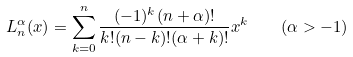Convert formula to latex. <formula><loc_0><loc_0><loc_500><loc_500>L _ { n } ^ { \alpha } ( x ) = \sum _ { k = 0 } ^ { n } \frac { ( - 1 ) ^ { k } ( n + \alpha ) ! } { k ! ( n - k ) ! ( \alpha + k ) ! } x ^ { k } \quad ( \alpha > - 1 )</formula> 